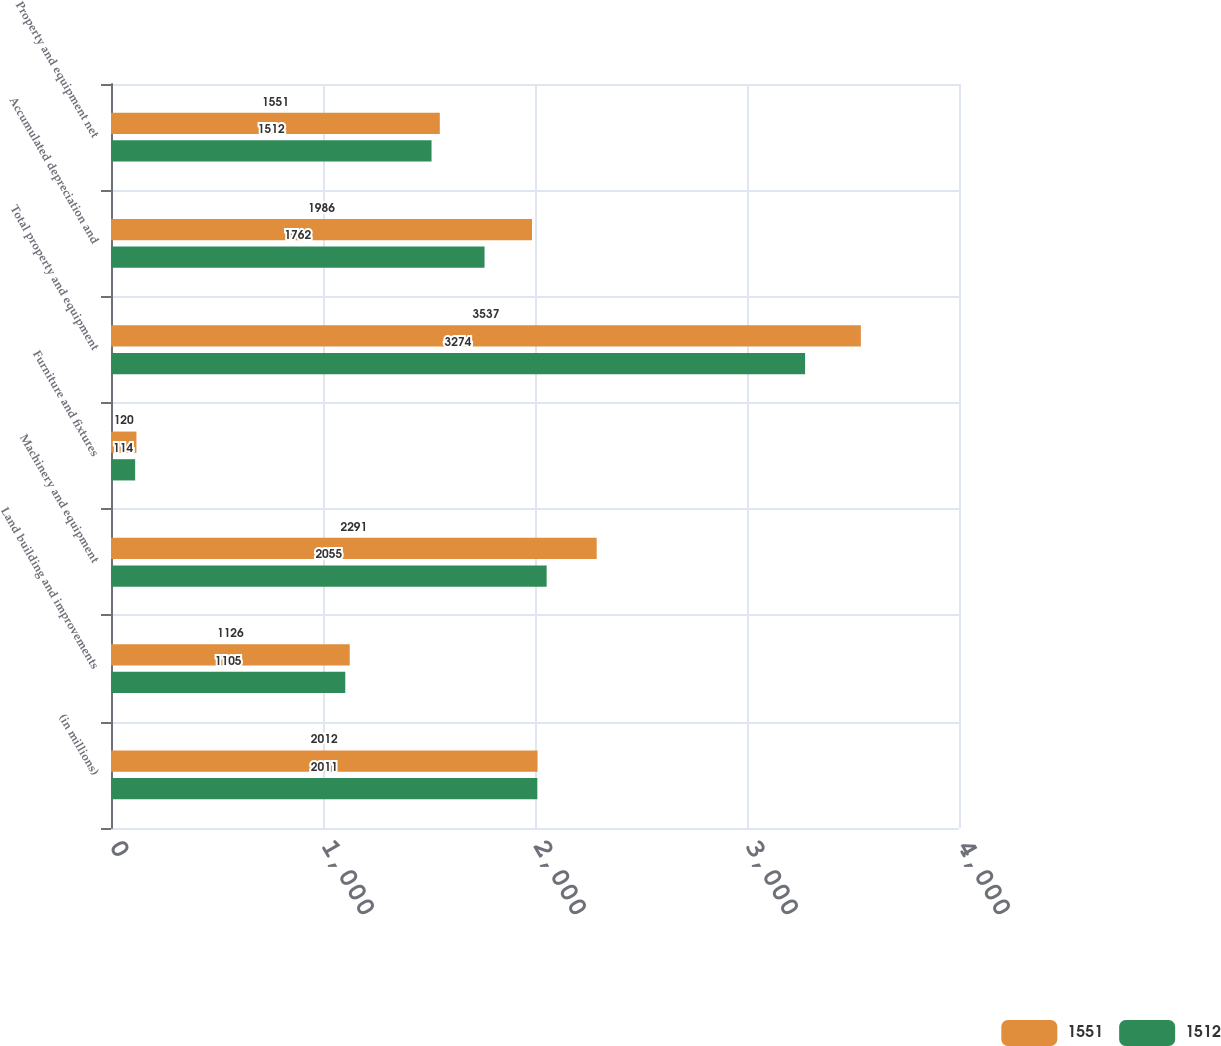<chart> <loc_0><loc_0><loc_500><loc_500><stacked_bar_chart><ecel><fcel>(in millions)<fcel>Land building and improvements<fcel>Machinery and equipment<fcel>Furniture and fixtures<fcel>Total property and equipment<fcel>Accumulated depreciation and<fcel>Property and equipment net<nl><fcel>1551<fcel>2012<fcel>1126<fcel>2291<fcel>120<fcel>3537<fcel>1986<fcel>1551<nl><fcel>1512<fcel>2011<fcel>1105<fcel>2055<fcel>114<fcel>3274<fcel>1762<fcel>1512<nl></chart> 